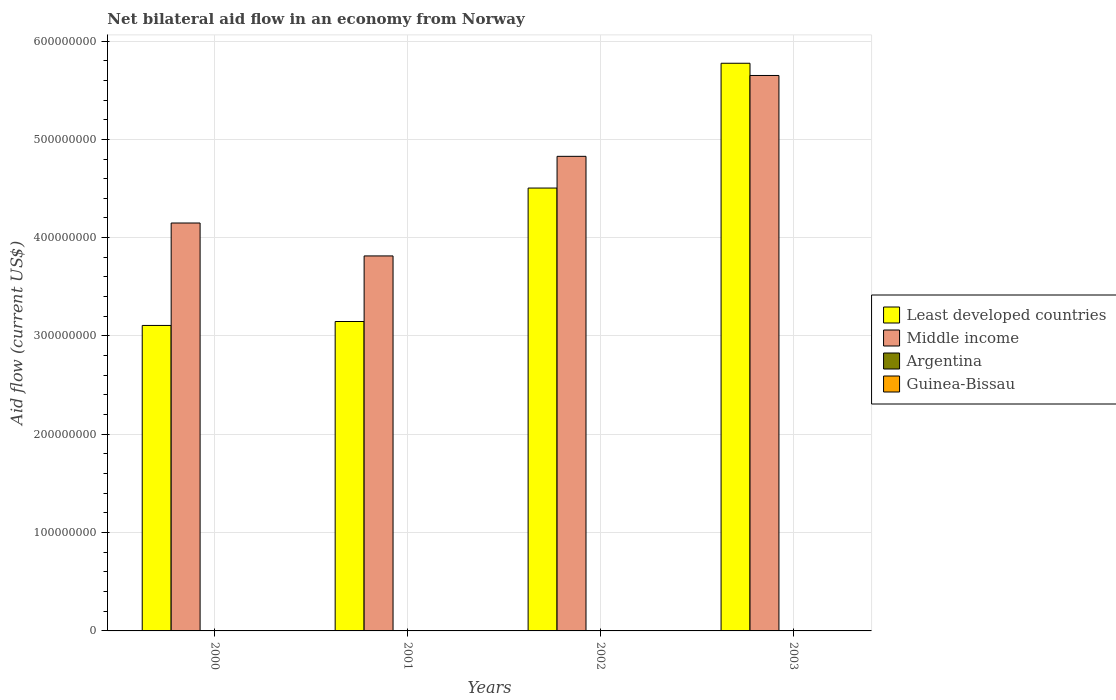How many different coloured bars are there?
Offer a terse response. 4. How many groups of bars are there?
Make the answer very short. 4. How many bars are there on the 3rd tick from the left?
Offer a very short reply. 4. How many bars are there on the 2nd tick from the right?
Your response must be concise. 4. In how many cases, is the number of bars for a given year not equal to the number of legend labels?
Give a very brief answer. 0. What is the net bilateral aid flow in Argentina in 2001?
Your answer should be very brief. 4.00e+04. Across all years, what is the maximum net bilateral aid flow in Middle income?
Keep it short and to the point. 5.65e+08. Across all years, what is the minimum net bilateral aid flow in Argentina?
Provide a short and direct response. 10000. In which year was the net bilateral aid flow in Guinea-Bissau minimum?
Ensure brevity in your answer.  2000. What is the total net bilateral aid flow in Middle income in the graph?
Provide a succinct answer. 1.84e+09. What is the difference between the net bilateral aid flow in Guinea-Bissau in 2000 and the net bilateral aid flow in Argentina in 2001?
Offer a terse response. -3.00e+04. What is the average net bilateral aid flow in Guinea-Bissau per year?
Give a very brief answer. 2.75e+04. In the year 2002, what is the difference between the net bilateral aid flow in Argentina and net bilateral aid flow in Middle income?
Your answer should be compact. -4.83e+08. What is the ratio of the net bilateral aid flow in Least developed countries in 2001 to that in 2002?
Provide a succinct answer. 0.7. What is the difference between the highest and the second highest net bilateral aid flow in Least developed countries?
Your response must be concise. 1.27e+08. Is the sum of the net bilateral aid flow in Least developed countries in 2000 and 2001 greater than the maximum net bilateral aid flow in Argentina across all years?
Make the answer very short. Yes. Is it the case that in every year, the sum of the net bilateral aid flow in Least developed countries and net bilateral aid flow in Argentina is greater than the sum of net bilateral aid flow in Middle income and net bilateral aid flow in Guinea-Bissau?
Keep it short and to the point. No. What does the 1st bar from the left in 2002 represents?
Ensure brevity in your answer.  Least developed countries. What does the 1st bar from the right in 2000 represents?
Offer a terse response. Guinea-Bissau. Are all the bars in the graph horizontal?
Provide a short and direct response. No. How many years are there in the graph?
Your answer should be very brief. 4. Does the graph contain any zero values?
Ensure brevity in your answer.  No. Does the graph contain grids?
Provide a succinct answer. Yes. Where does the legend appear in the graph?
Your response must be concise. Center right. How are the legend labels stacked?
Offer a very short reply. Vertical. What is the title of the graph?
Make the answer very short. Net bilateral aid flow in an economy from Norway. What is the label or title of the X-axis?
Make the answer very short. Years. What is the Aid flow (current US$) of Least developed countries in 2000?
Provide a succinct answer. 3.11e+08. What is the Aid flow (current US$) in Middle income in 2000?
Offer a terse response. 4.15e+08. What is the Aid flow (current US$) in Guinea-Bissau in 2000?
Your answer should be very brief. 10000. What is the Aid flow (current US$) in Least developed countries in 2001?
Ensure brevity in your answer.  3.15e+08. What is the Aid flow (current US$) in Middle income in 2001?
Give a very brief answer. 3.81e+08. What is the Aid flow (current US$) of Guinea-Bissau in 2001?
Provide a succinct answer. 2.00e+04. What is the Aid flow (current US$) of Least developed countries in 2002?
Offer a terse response. 4.50e+08. What is the Aid flow (current US$) in Middle income in 2002?
Offer a terse response. 4.83e+08. What is the Aid flow (current US$) in Least developed countries in 2003?
Ensure brevity in your answer.  5.77e+08. What is the Aid flow (current US$) in Middle income in 2003?
Provide a succinct answer. 5.65e+08. Across all years, what is the maximum Aid flow (current US$) in Least developed countries?
Give a very brief answer. 5.77e+08. Across all years, what is the maximum Aid flow (current US$) in Middle income?
Ensure brevity in your answer.  5.65e+08. Across all years, what is the maximum Aid flow (current US$) in Guinea-Bissau?
Ensure brevity in your answer.  5.00e+04. Across all years, what is the minimum Aid flow (current US$) of Least developed countries?
Make the answer very short. 3.11e+08. Across all years, what is the minimum Aid flow (current US$) of Middle income?
Ensure brevity in your answer.  3.81e+08. What is the total Aid flow (current US$) of Least developed countries in the graph?
Offer a very short reply. 1.65e+09. What is the total Aid flow (current US$) in Middle income in the graph?
Provide a short and direct response. 1.84e+09. What is the total Aid flow (current US$) of Argentina in the graph?
Offer a terse response. 5.10e+05. What is the difference between the Aid flow (current US$) in Middle income in 2000 and that in 2001?
Offer a very short reply. 3.35e+07. What is the difference between the Aid flow (current US$) in Argentina in 2000 and that in 2001?
Your response must be concise. -3.00e+04. What is the difference between the Aid flow (current US$) in Guinea-Bissau in 2000 and that in 2001?
Your answer should be compact. -10000. What is the difference between the Aid flow (current US$) in Least developed countries in 2000 and that in 2002?
Provide a short and direct response. -1.40e+08. What is the difference between the Aid flow (current US$) of Middle income in 2000 and that in 2002?
Provide a short and direct response. -6.78e+07. What is the difference between the Aid flow (current US$) of Least developed countries in 2000 and that in 2003?
Offer a very short reply. -2.67e+08. What is the difference between the Aid flow (current US$) of Middle income in 2000 and that in 2003?
Offer a very short reply. -1.50e+08. What is the difference between the Aid flow (current US$) in Argentina in 2000 and that in 2003?
Give a very brief answer. -3.60e+05. What is the difference between the Aid flow (current US$) in Least developed countries in 2001 and that in 2002?
Your answer should be very brief. -1.36e+08. What is the difference between the Aid flow (current US$) in Middle income in 2001 and that in 2002?
Make the answer very short. -1.01e+08. What is the difference between the Aid flow (current US$) of Argentina in 2001 and that in 2002?
Your answer should be compact. -5.00e+04. What is the difference between the Aid flow (current US$) in Guinea-Bissau in 2001 and that in 2002?
Offer a terse response. -10000. What is the difference between the Aid flow (current US$) in Least developed countries in 2001 and that in 2003?
Your answer should be compact. -2.63e+08. What is the difference between the Aid flow (current US$) of Middle income in 2001 and that in 2003?
Ensure brevity in your answer.  -1.84e+08. What is the difference between the Aid flow (current US$) in Argentina in 2001 and that in 2003?
Provide a short and direct response. -3.30e+05. What is the difference between the Aid flow (current US$) in Least developed countries in 2002 and that in 2003?
Your answer should be very brief. -1.27e+08. What is the difference between the Aid flow (current US$) of Middle income in 2002 and that in 2003?
Offer a very short reply. -8.23e+07. What is the difference between the Aid flow (current US$) in Argentina in 2002 and that in 2003?
Make the answer very short. -2.80e+05. What is the difference between the Aid flow (current US$) in Guinea-Bissau in 2002 and that in 2003?
Offer a very short reply. -2.00e+04. What is the difference between the Aid flow (current US$) of Least developed countries in 2000 and the Aid flow (current US$) of Middle income in 2001?
Keep it short and to the point. -7.07e+07. What is the difference between the Aid flow (current US$) of Least developed countries in 2000 and the Aid flow (current US$) of Argentina in 2001?
Your response must be concise. 3.11e+08. What is the difference between the Aid flow (current US$) in Least developed countries in 2000 and the Aid flow (current US$) in Guinea-Bissau in 2001?
Offer a terse response. 3.11e+08. What is the difference between the Aid flow (current US$) of Middle income in 2000 and the Aid flow (current US$) of Argentina in 2001?
Your answer should be compact. 4.15e+08. What is the difference between the Aid flow (current US$) of Middle income in 2000 and the Aid flow (current US$) of Guinea-Bissau in 2001?
Provide a short and direct response. 4.15e+08. What is the difference between the Aid flow (current US$) in Argentina in 2000 and the Aid flow (current US$) in Guinea-Bissau in 2001?
Your answer should be very brief. -10000. What is the difference between the Aid flow (current US$) in Least developed countries in 2000 and the Aid flow (current US$) in Middle income in 2002?
Keep it short and to the point. -1.72e+08. What is the difference between the Aid flow (current US$) in Least developed countries in 2000 and the Aid flow (current US$) in Argentina in 2002?
Provide a succinct answer. 3.11e+08. What is the difference between the Aid flow (current US$) in Least developed countries in 2000 and the Aid flow (current US$) in Guinea-Bissau in 2002?
Offer a terse response. 3.11e+08. What is the difference between the Aid flow (current US$) of Middle income in 2000 and the Aid flow (current US$) of Argentina in 2002?
Give a very brief answer. 4.15e+08. What is the difference between the Aid flow (current US$) of Middle income in 2000 and the Aid flow (current US$) of Guinea-Bissau in 2002?
Make the answer very short. 4.15e+08. What is the difference between the Aid flow (current US$) of Argentina in 2000 and the Aid flow (current US$) of Guinea-Bissau in 2002?
Give a very brief answer. -2.00e+04. What is the difference between the Aid flow (current US$) in Least developed countries in 2000 and the Aid flow (current US$) in Middle income in 2003?
Offer a very short reply. -2.54e+08. What is the difference between the Aid flow (current US$) of Least developed countries in 2000 and the Aid flow (current US$) of Argentina in 2003?
Your answer should be very brief. 3.10e+08. What is the difference between the Aid flow (current US$) of Least developed countries in 2000 and the Aid flow (current US$) of Guinea-Bissau in 2003?
Your response must be concise. 3.11e+08. What is the difference between the Aid flow (current US$) in Middle income in 2000 and the Aid flow (current US$) in Argentina in 2003?
Ensure brevity in your answer.  4.15e+08. What is the difference between the Aid flow (current US$) in Middle income in 2000 and the Aid flow (current US$) in Guinea-Bissau in 2003?
Provide a short and direct response. 4.15e+08. What is the difference between the Aid flow (current US$) of Least developed countries in 2001 and the Aid flow (current US$) of Middle income in 2002?
Your answer should be compact. -1.68e+08. What is the difference between the Aid flow (current US$) of Least developed countries in 2001 and the Aid flow (current US$) of Argentina in 2002?
Make the answer very short. 3.15e+08. What is the difference between the Aid flow (current US$) in Least developed countries in 2001 and the Aid flow (current US$) in Guinea-Bissau in 2002?
Keep it short and to the point. 3.15e+08. What is the difference between the Aid flow (current US$) in Middle income in 2001 and the Aid flow (current US$) in Argentina in 2002?
Your response must be concise. 3.81e+08. What is the difference between the Aid flow (current US$) in Middle income in 2001 and the Aid flow (current US$) in Guinea-Bissau in 2002?
Offer a terse response. 3.81e+08. What is the difference between the Aid flow (current US$) in Least developed countries in 2001 and the Aid flow (current US$) in Middle income in 2003?
Keep it short and to the point. -2.50e+08. What is the difference between the Aid flow (current US$) of Least developed countries in 2001 and the Aid flow (current US$) of Argentina in 2003?
Your response must be concise. 3.14e+08. What is the difference between the Aid flow (current US$) of Least developed countries in 2001 and the Aid flow (current US$) of Guinea-Bissau in 2003?
Your answer should be compact. 3.15e+08. What is the difference between the Aid flow (current US$) of Middle income in 2001 and the Aid flow (current US$) of Argentina in 2003?
Your response must be concise. 3.81e+08. What is the difference between the Aid flow (current US$) of Middle income in 2001 and the Aid flow (current US$) of Guinea-Bissau in 2003?
Keep it short and to the point. 3.81e+08. What is the difference between the Aid flow (current US$) of Least developed countries in 2002 and the Aid flow (current US$) of Middle income in 2003?
Ensure brevity in your answer.  -1.15e+08. What is the difference between the Aid flow (current US$) of Least developed countries in 2002 and the Aid flow (current US$) of Argentina in 2003?
Give a very brief answer. 4.50e+08. What is the difference between the Aid flow (current US$) of Least developed countries in 2002 and the Aid flow (current US$) of Guinea-Bissau in 2003?
Ensure brevity in your answer.  4.50e+08. What is the difference between the Aid flow (current US$) of Middle income in 2002 and the Aid flow (current US$) of Argentina in 2003?
Provide a succinct answer. 4.82e+08. What is the difference between the Aid flow (current US$) in Middle income in 2002 and the Aid flow (current US$) in Guinea-Bissau in 2003?
Give a very brief answer. 4.83e+08. What is the average Aid flow (current US$) of Least developed countries per year?
Give a very brief answer. 4.13e+08. What is the average Aid flow (current US$) in Middle income per year?
Give a very brief answer. 4.61e+08. What is the average Aid flow (current US$) of Argentina per year?
Give a very brief answer. 1.28e+05. What is the average Aid flow (current US$) of Guinea-Bissau per year?
Your answer should be compact. 2.75e+04. In the year 2000, what is the difference between the Aid flow (current US$) of Least developed countries and Aid flow (current US$) of Middle income?
Your response must be concise. -1.04e+08. In the year 2000, what is the difference between the Aid flow (current US$) in Least developed countries and Aid flow (current US$) in Argentina?
Your response must be concise. 3.11e+08. In the year 2000, what is the difference between the Aid flow (current US$) of Least developed countries and Aid flow (current US$) of Guinea-Bissau?
Provide a succinct answer. 3.11e+08. In the year 2000, what is the difference between the Aid flow (current US$) of Middle income and Aid flow (current US$) of Argentina?
Your answer should be very brief. 4.15e+08. In the year 2000, what is the difference between the Aid flow (current US$) of Middle income and Aid flow (current US$) of Guinea-Bissau?
Provide a succinct answer. 4.15e+08. In the year 2000, what is the difference between the Aid flow (current US$) of Argentina and Aid flow (current US$) of Guinea-Bissau?
Ensure brevity in your answer.  0. In the year 2001, what is the difference between the Aid flow (current US$) of Least developed countries and Aid flow (current US$) of Middle income?
Provide a succinct answer. -6.67e+07. In the year 2001, what is the difference between the Aid flow (current US$) in Least developed countries and Aid flow (current US$) in Argentina?
Offer a terse response. 3.15e+08. In the year 2001, what is the difference between the Aid flow (current US$) in Least developed countries and Aid flow (current US$) in Guinea-Bissau?
Offer a terse response. 3.15e+08. In the year 2001, what is the difference between the Aid flow (current US$) in Middle income and Aid flow (current US$) in Argentina?
Your answer should be very brief. 3.81e+08. In the year 2001, what is the difference between the Aid flow (current US$) of Middle income and Aid flow (current US$) of Guinea-Bissau?
Offer a terse response. 3.81e+08. In the year 2002, what is the difference between the Aid flow (current US$) in Least developed countries and Aid flow (current US$) in Middle income?
Keep it short and to the point. -3.22e+07. In the year 2002, what is the difference between the Aid flow (current US$) of Least developed countries and Aid flow (current US$) of Argentina?
Offer a very short reply. 4.50e+08. In the year 2002, what is the difference between the Aid flow (current US$) of Least developed countries and Aid flow (current US$) of Guinea-Bissau?
Provide a short and direct response. 4.50e+08. In the year 2002, what is the difference between the Aid flow (current US$) in Middle income and Aid flow (current US$) in Argentina?
Give a very brief answer. 4.83e+08. In the year 2002, what is the difference between the Aid flow (current US$) in Middle income and Aid flow (current US$) in Guinea-Bissau?
Provide a succinct answer. 4.83e+08. In the year 2003, what is the difference between the Aid flow (current US$) in Least developed countries and Aid flow (current US$) in Middle income?
Make the answer very short. 1.24e+07. In the year 2003, what is the difference between the Aid flow (current US$) in Least developed countries and Aid flow (current US$) in Argentina?
Give a very brief answer. 5.77e+08. In the year 2003, what is the difference between the Aid flow (current US$) of Least developed countries and Aid flow (current US$) of Guinea-Bissau?
Offer a terse response. 5.77e+08. In the year 2003, what is the difference between the Aid flow (current US$) in Middle income and Aid flow (current US$) in Argentina?
Your answer should be very brief. 5.65e+08. In the year 2003, what is the difference between the Aid flow (current US$) in Middle income and Aid flow (current US$) in Guinea-Bissau?
Provide a short and direct response. 5.65e+08. What is the ratio of the Aid flow (current US$) of Least developed countries in 2000 to that in 2001?
Keep it short and to the point. 0.99. What is the ratio of the Aid flow (current US$) of Middle income in 2000 to that in 2001?
Keep it short and to the point. 1.09. What is the ratio of the Aid flow (current US$) of Guinea-Bissau in 2000 to that in 2001?
Make the answer very short. 0.5. What is the ratio of the Aid flow (current US$) of Least developed countries in 2000 to that in 2002?
Offer a very short reply. 0.69. What is the ratio of the Aid flow (current US$) in Middle income in 2000 to that in 2002?
Keep it short and to the point. 0.86. What is the ratio of the Aid flow (current US$) of Guinea-Bissau in 2000 to that in 2002?
Provide a short and direct response. 0.33. What is the ratio of the Aid flow (current US$) of Least developed countries in 2000 to that in 2003?
Offer a very short reply. 0.54. What is the ratio of the Aid flow (current US$) in Middle income in 2000 to that in 2003?
Offer a terse response. 0.73. What is the ratio of the Aid flow (current US$) in Argentina in 2000 to that in 2003?
Your response must be concise. 0.03. What is the ratio of the Aid flow (current US$) of Least developed countries in 2001 to that in 2002?
Offer a terse response. 0.7. What is the ratio of the Aid flow (current US$) in Middle income in 2001 to that in 2002?
Give a very brief answer. 0.79. What is the ratio of the Aid flow (current US$) of Argentina in 2001 to that in 2002?
Your answer should be very brief. 0.44. What is the ratio of the Aid flow (current US$) in Least developed countries in 2001 to that in 2003?
Offer a terse response. 0.55. What is the ratio of the Aid flow (current US$) in Middle income in 2001 to that in 2003?
Keep it short and to the point. 0.68. What is the ratio of the Aid flow (current US$) of Argentina in 2001 to that in 2003?
Offer a very short reply. 0.11. What is the ratio of the Aid flow (current US$) of Guinea-Bissau in 2001 to that in 2003?
Your answer should be very brief. 0.4. What is the ratio of the Aid flow (current US$) in Least developed countries in 2002 to that in 2003?
Ensure brevity in your answer.  0.78. What is the ratio of the Aid flow (current US$) in Middle income in 2002 to that in 2003?
Provide a short and direct response. 0.85. What is the ratio of the Aid flow (current US$) of Argentina in 2002 to that in 2003?
Provide a short and direct response. 0.24. What is the difference between the highest and the second highest Aid flow (current US$) in Least developed countries?
Provide a succinct answer. 1.27e+08. What is the difference between the highest and the second highest Aid flow (current US$) of Middle income?
Your answer should be compact. 8.23e+07. What is the difference between the highest and the second highest Aid flow (current US$) of Argentina?
Provide a succinct answer. 2.80e+05. What is the difference between the highest and the lowest Aid flow (current US$) of Least developed countries?
Your answer should be compact. 2.67e+08. What is the difference between the highest and the lowest Aid flow (current US$) of Middle income?
Your response must be concise. 1.84e+08. What is the difference between the highest and the lowest Aid flow (current US$) in Guinea-Bissau?
Offer a terse response. 4.00e+04. 